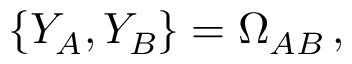Convert formula to latex. <formula><loc_0><loc_0><loc_500><loc_500>\{ Y _ { A } , Y _ { B } \} = \Omega _ { A B } \, ,</formula> 